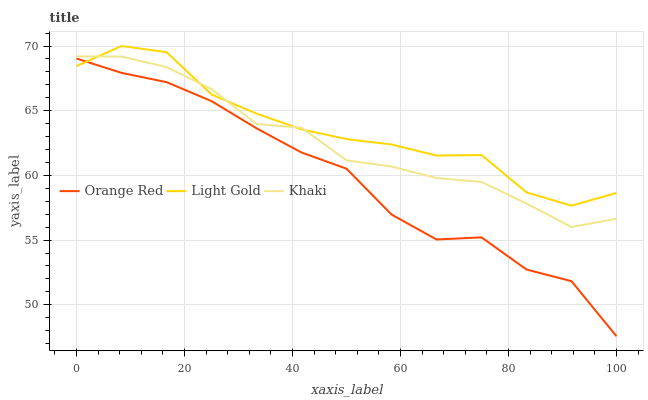Does Orange Red have the minimum area under the curve?
Answer yes or no. Yes. Does Light Gold have the maximum area under the curve?
Answer yes or no. Yes. Does Light Gold have the minimum area under the curve?
Answer yes or no. No. Does Orange Red have the maximum area under the curve?
Answer yes or no. No. Is Khaki the smoothest?
Answer yes or no. Yes. Is Orange Red the roughest?
Answer yes or no. Yes. Is Light Gold the smoothest?
Answer yes or no. No. Is Light Gold the roughest?
Answer yes or no. No. Does Orange Red have the lowest value?
Answer yes or no. Yes. Does Light Gold have the lowest value?
Answer yes or no. No. Does Light Gold have the highest value?
Answer yes or no. Yes. Does Orange Red have the highest value?
Answer yes or no. No. Is Orange Red less than Khaki?
Answer yes or no. Yes. Is Khaki greater than Orange Red?
Answer yes or no. Yes. Does Orange Red intersect Light Gold?
Answer yes or no. Yes. Is Orange Red less than Light Gold?
Answer yes or no. No. Is Orange Red greater than Light Gold?
Answer yes or no. No. Does Orange Red intersect Khaki?
Answer yes or no. No. 